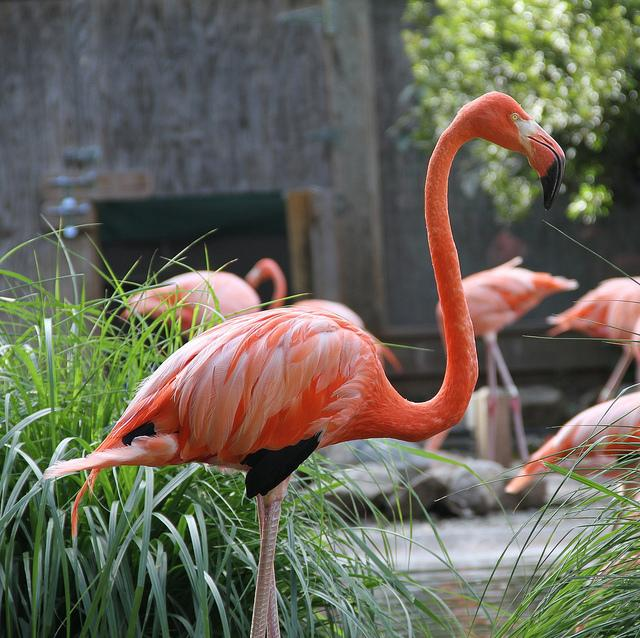How many birds are in focus? Please explain your reasoning. one. While there are several birds in the picture, the features of only the one closest to the camera can be clearly identified. 